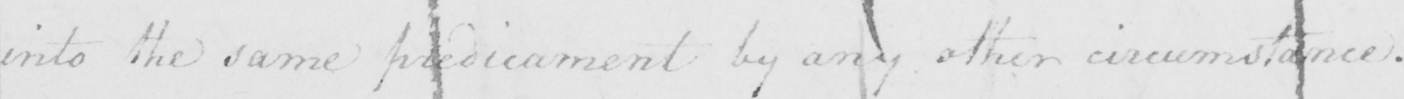What does this handwritten line say? into the same predicament by any other circumstance . 